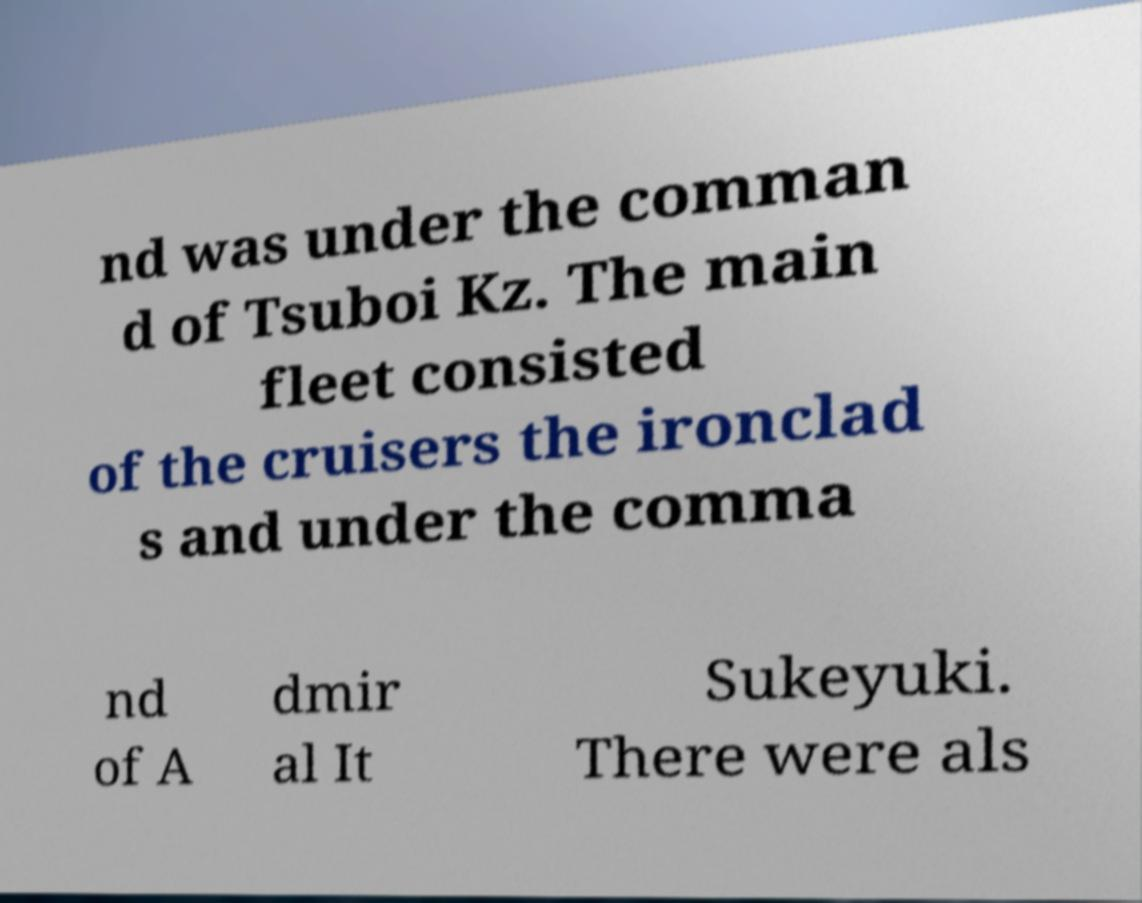Can you accurately transcribe the text from the provided image for me? nd was under the comman d of Tsuboi Kz. The main fleet consisted of the cruisers the ironclad s and under the comma nd of A dmir al It Sukeyuki. There were als 